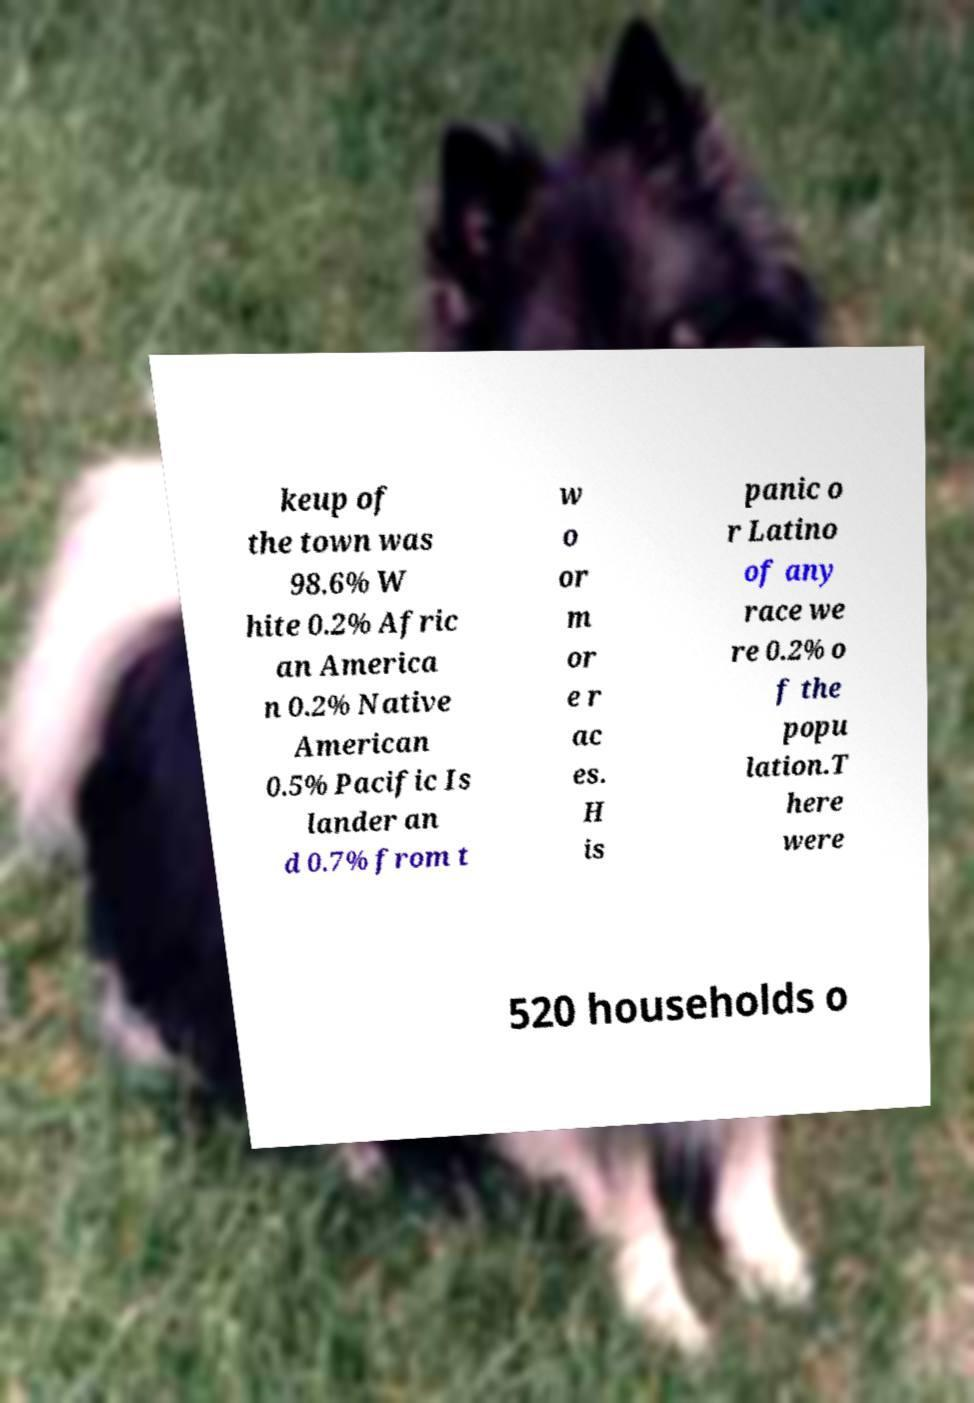Could you extract and type out the text from this image? keup of the town was 98.6% W hite 0.2% Afric an America n 0.2% Native American 0.5% Pacific Is lander an d 0.7% from t w o or m or e r ac es. H is panic o r Latino of any race we re 0.2% o f the popu lation.T here were 520 households o 